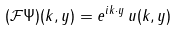<formula> <loc_0><loc_0><loc_500><loc_500>( \mathcal { F } \Psi ) ( k , y ) = e ^ { i k \cdot y } \, u ( k , y )</formula> 